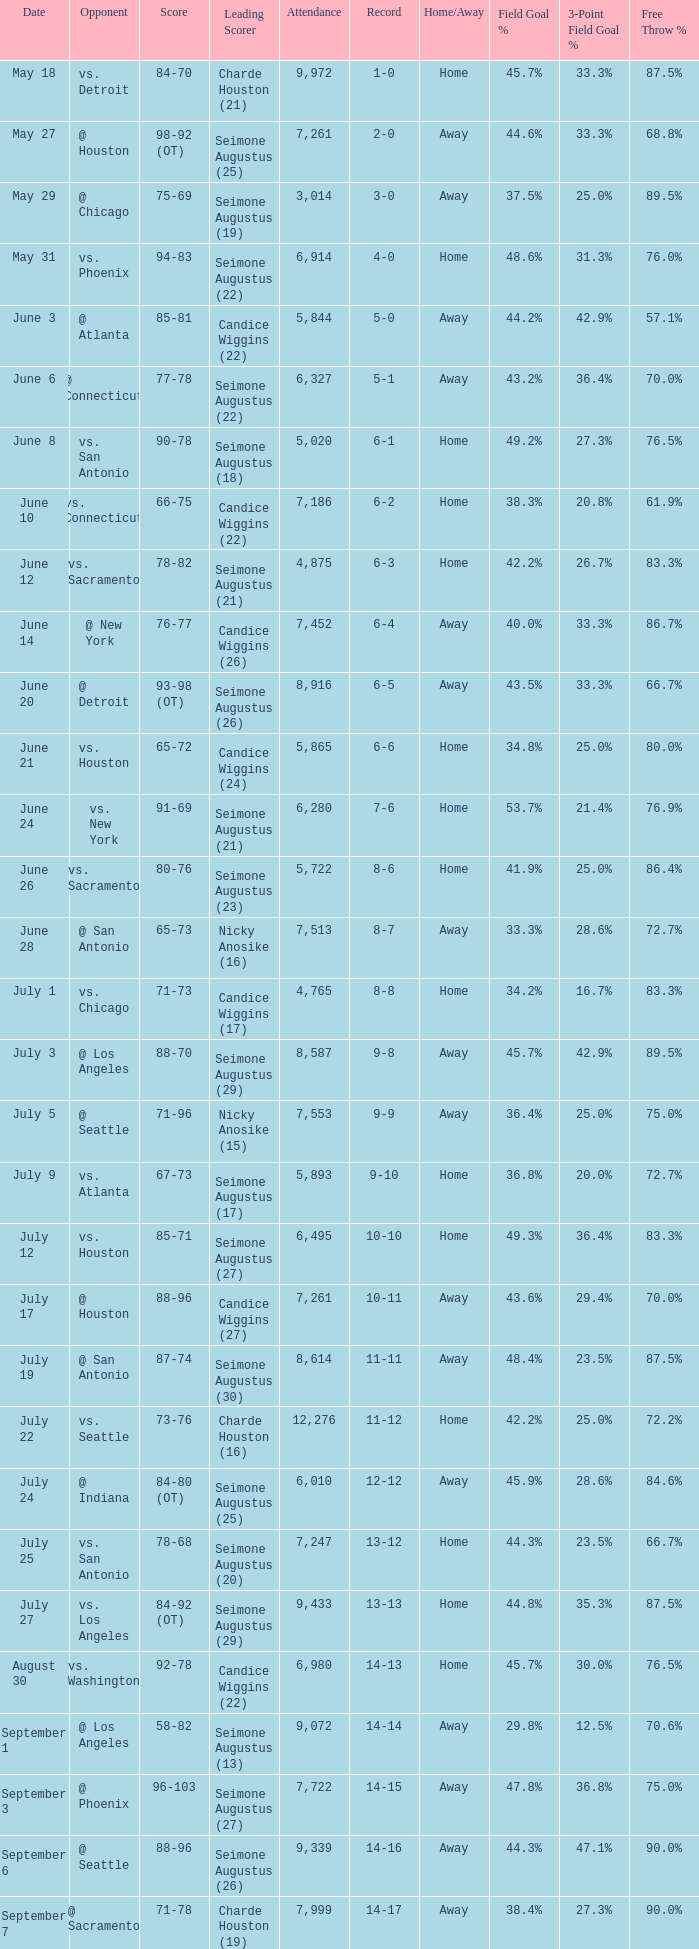Which Attendance has a Date of september 7? 7999.0. 